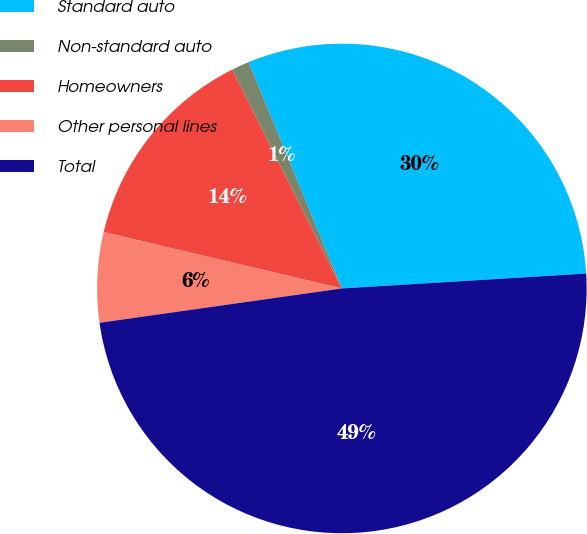Convert chart to OTSL. <chart><loc_0><loc_0><loc_500><loc_500><pie_chart><fcel>Standard auto<fcel>Non-standard auto<fcel>Homeowners<fcel>Other personal lines<fcel>Total<nl><fcel>30.25%<fcel>1.18%<fcel>13.9%<fcel>5.94%<fcel>48.73%<nl></chart> 